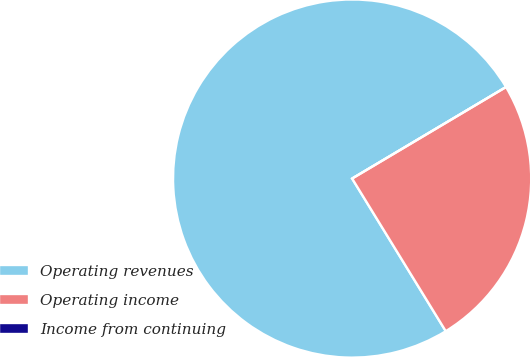Convert chart to OTSL. <chart><loc_0><loc_0><loc_500><loc_500><pie_chart><fcel>Operating revenues<fcel>Operating income<fcel>Income from continuing<nl><fcel>75.22%<fcel>24.78%<fcel>0.0%<nl></chart> 